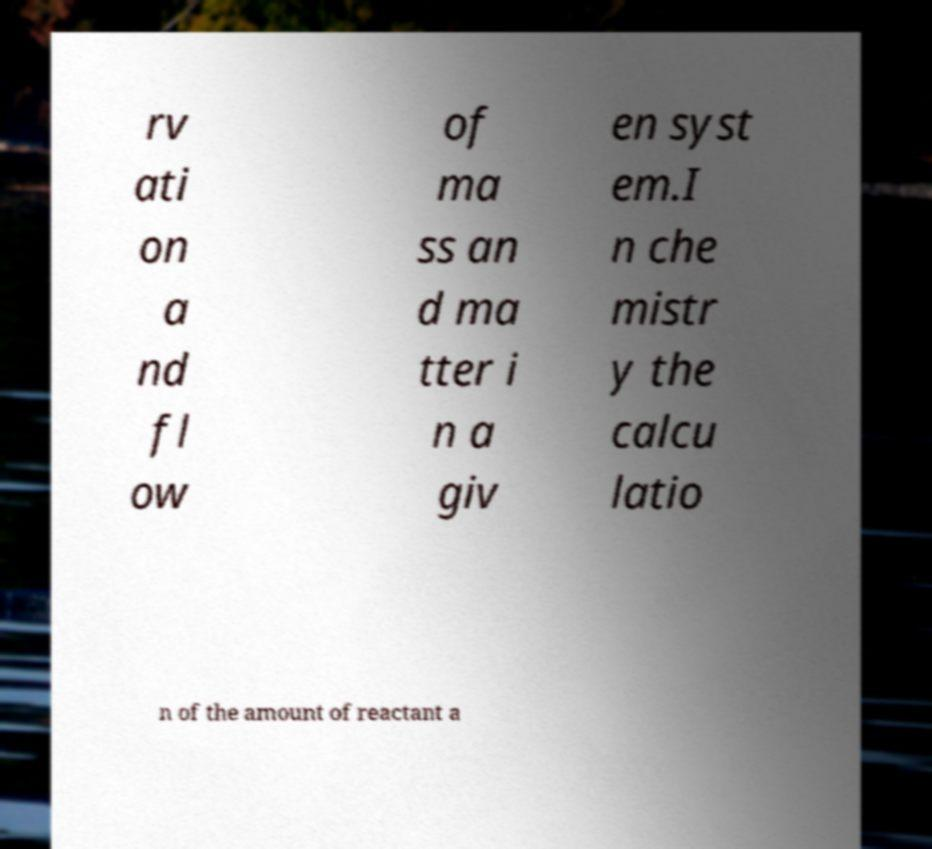Please identify and transcribe the text found in this image. rv ati on a nd fl ow of ma ss an d ma tter i n a giv en syst em.I n che mistr y the calcu latio n of the amount of reactant a 